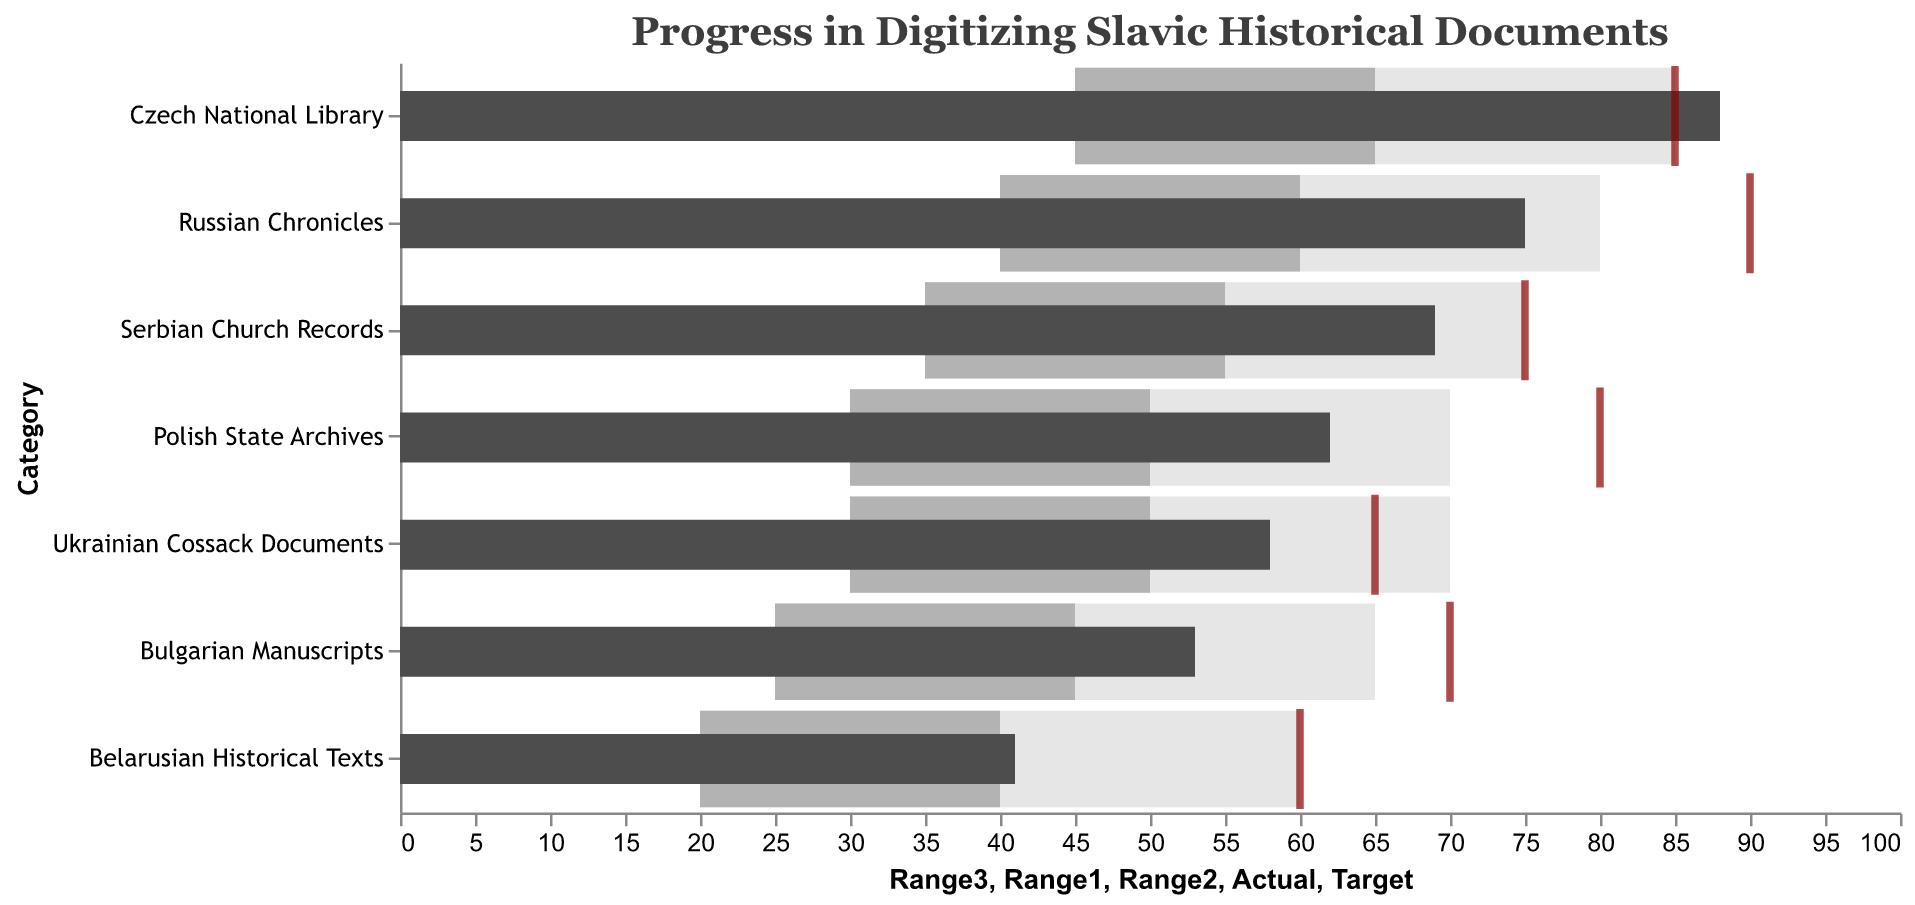What is the title of the chart? The chart's title is given in the code as "Progress in Digitizing Slavic Historical Documents".
Answer: Progress in Digitizing Slavic Historical Documents Which category has the highest actual progress in digitizing documents? To find the highest actual progress, we look at the "Actual" column and identify the category with the highest value. The Czech National Library has an actual value of 88, which is the highest.
Answer: Czech National Library Did any category surpass its target? We compare the "Actual" and "Target" values. The Czech National Library has an actual progress of 88, which surpasses its target of 85.
Answer: Yes, the Czech National Library Which category has the lowest actual progress in digitizing documents? We look at the "Actual" column and identify the category with the lowest value. Belarusian Historical Texts have the lowest actual progress at 41.
Answer: Belarusian Historical Texts How does the progress of the Polish State Archives compare to its target? The Polish State Archives has an actual progress of 62 and a target of 80. It has not yet reached its target.
Answer: Below target What category has the closest actual progress to its target? We calculate the differences between "Actual" and "Target" for each category. Czech National Library has an actual progress of 88 and a target of 85, which is the closest difference of 3.
Answer: Czech National Library Which category has the widest gap between its lowest range and its actual progress? We calculate the differences between the "Range1" and "Actual" for each category. The Russian Chronicles have the widest gap with a difference of 75 - 40 = 35.
Answer: Russian Chronicles Compare the Bulgarian Manuscripts and Serbian Church Records in terms of actual progress against their targets. Bulgarian Manuscripts have an actual progress of 53 with a target of 70, while Serbian Church Records have an actual progress of 69 with a target of 75. Both are below target, but Serbian Church Records are closer to their target.
Answer: Both are below target; Serbian Church Records are closer Identify any categories where the actual progress falls within the second range (Range2). We look at the "Actual" values that fall within "Range2". Polish State Archives (62) and Ukrainian Cossack Documents (58) both fall within their respective Range2.
Answer: Polish State Archives, Ukrainian Cossack Documents What is the average actual progress of all categories? To find the average, we sum all the "Actual" values: 75 + 62 + 88 + 53 + 69 + 58 + 41 = 446. Dividing by the number of categories (7) gives us an average of 446 / 7 ≈ 63.71.
Answer: Approximately 63.71 